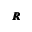<formula> <loc_0><loc_0><loc_500><loc_500>\pm b { R }</formula> 